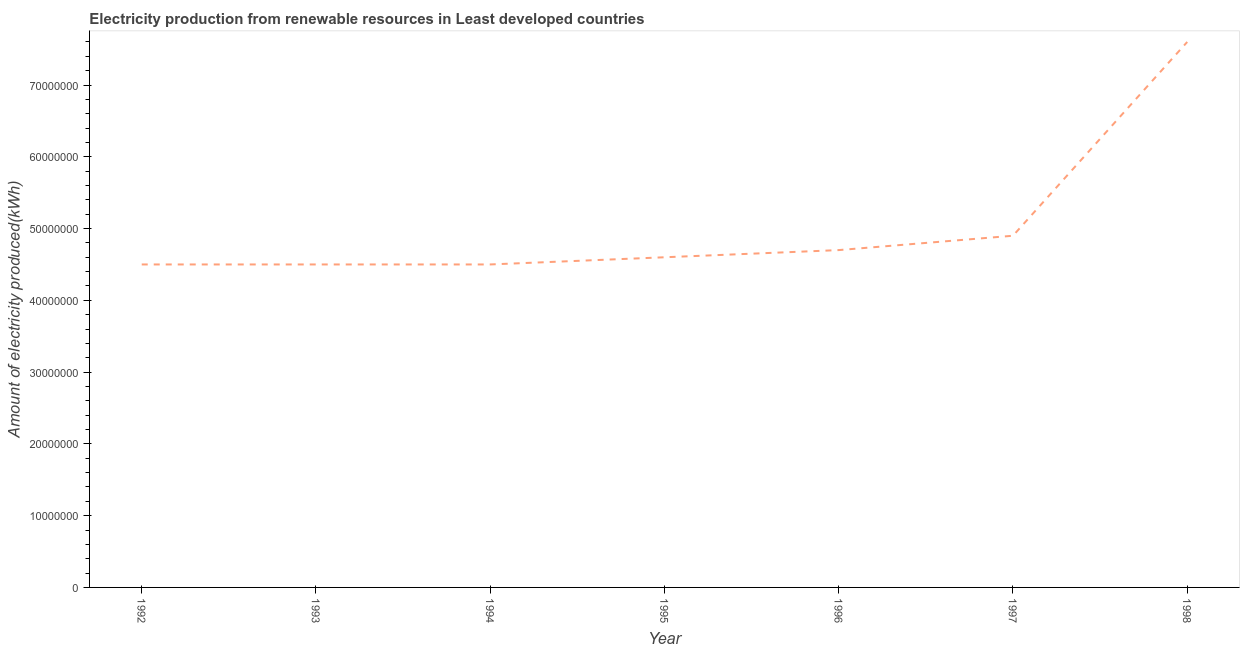What is the amount of electricity produced in 1998?
Your answer should be very brief. 7.60e+07. Across all years, what is the maximum amount of electricity produced?
Your response must be concise. 7.60e+07. Across all years, what is the minimum amount of electricity produced?
Offer a very short reply. 4.50e+07. In which year was the amount of electricity produced minimum?
Provide a short and direct response. 1992. What is the sum of the amount of electricity produced?
Offer a very short reply. 3.53e+08. What is the difference between the amount of electricity produced in 1995 and 1997?
Provide a succinct answer. -3.00e+06. What is the average amount of electricity produced per year?
Your answer should be very brief. 5.04e+07. What is the median amount of electricity produced?
Your answer should be very brief. 4.60e+07. What is the ratio of the amount of electricity produced in 1992 to that in 1996?
Keep it short and to the point. 0.96. Is the amount of electricity produced in 1993 less than that in 1996?
Keep it short and to the point. Yes. Is the difference between the amount of electricity produced in 1996 and 1997 greater than the difference between any two years?
Keep it short and to the point. No. What is the difference between the highest and the second highest amount of electricity produced?
Keep it short and to the point. 2.70e+07. Is the sum of the amount of electricity produced in 1996 and 1998 greater than the maximum amount of electricity produced across all years?
Ensure brevity in your answer.  Yes. What is the difference between the highest and the lowest amount of electricity produced?
Your answer should be compact. 3.10e+07. In how many years, is the amount of electricity produced greater than the average amount of electricity produced taken over all years?
Provide a short and direct response. 1. How many lines are there?
Your answer should be very brief. 1. Does the graph contain any zero values?
Your answer should be compact. No. Does the graph contain grids?
Give a very brief answer. No. What is the title of the graph?
Ensure brevity in your answer.  Electricity production from renewable resources in Least developed countries. What is the label or title of the X-axis?
Your answer should be compact. Year. What is the label or title of the Y-axis?
Keep it short and to the point. Amount of electricity produced(kWh). What is the Amount of electricity produced(kWh) of 1992?
Your answer should be compact. 4.50e+07. What is the Amount of electricity produced(kWh) of 1993?
Your answer should be very brief. 4.50e+07. What is the Amount of electricity produced(kWh) in 1994?
Give a very brief answer. 4.50e+07. What is the Amount of electricity produced(kWh) in 1995?
Your answer should be very brief. 4.60e+07. What is the Amount of electricity produced(kWh) in 1996?
Provide a short and direct response. 4.70e+07. What is the Amount of electricity produced(kWh) of 1997?
Provide a succinct answer. 4.90e+07. What is the Amount of electricity produced(kWh) in 1998?
Give a very brief answer. 7.60e+07. What is the difference between the Amount of electricity produced(kWh) in 1992 and 1995?
Provide a succinct answer. -1.00e+06. What is the difference between the Amount of electricity produced(kWh) in 1992 and 1997?
Offer a very short reply. -4.00e+06. What is the difference between the Amount of electricity produced(kWh) in 1992 and 1998?
Your response must be concise. -3.10e+07. What is the difference between the Amount of electricity produced(kWh) in 1993 and 1994?
Offer a terse response. 0. What is the difference between the Amount of electricity produced(kWh) in 1993 and 1995?
Give a very brief answer. -1.00e+06. What is the difference between the Amount of electricity produced(kWh) in 1993 and 1998?
Make the answer very short. -3.10e+07. What is the difference between the Amount of electricity produced(kWh) in 1994 and 1997?
Your answer should be very brief. -4.00e+06. What is the difference between the Amount of electricity produced(kWh) in 1994 and 1998?
Provide a short and direct response. -3.10e+07. What is the difference between the Amount of electricity produced(kWh) in 1995 and 1997?
Give a very brief answer. -3.00e+06. What is the difference between the Amount of electricity produced(kWh) in 1995 and 1998?
Give a very brief answer. -3.00e+07. What is the difference between the Amount of electricity produced(kWh) in 1996 and 1998?
Keep it short and to the point. -2.90e+07. What is the difference between the Amount of electricity produced(kWh) in 1997 and 1998?
Keep it short and to the point. -2.70e+07. What is the ratio of the Amount of electricity produced(kWh) in 1992 to that in 1993?
Make the answer very short. 1. What is the ratio of the Amount of electricity produced(kWh) in 1992 to that in 1994?
Your response must be concise. 1. What is the ratio of the Amount of electricity produced(kWh) in 1992 to that in 1995?
Ensure brevity in your answer.  0.98. What is the ratio of the Amount of electricity produced(kWh) in 1992 to that in 1996?
Give a very brief answer. 0.96. What is the ratio of the Amount of electricity produced(kWh) in 1992 to that in 1997?
Your response must be concise. 0.92. What is the ratio of the Amount of electricity produced(kWh) in 1992 to that in 1998?
Give a very brief answer. 0.59. What is the ratio of the Amount of electricity produced(kWh) in 1993 to that in 1997?
Give a very brief answer. 0.92. What is the ratio of the Amount of electricity produced(kWh) in 1993 to that in 1998?
Your response must be concise. 0.59. What is the ratio of the Amount of electricity produced(kWh) in 1994 to that in 1995?
Give a very brief answer. 0.98. What is the ratio of the Amount of electricity produced(kWh) in 1994 to that in 1997?
Offer a very short reply. 0.92. What is the ratio of the Amount of electricity produced(kWh) in 1994 to that in 1998?
Your answer should be compact. 0.59. What is the ratio of the Amount of electricity produced(kWh) in 1995 to that in 1997?
Offer a terse response. 0.94. What is the ratio of the Amount of electricity produced(kWh) in 1995 to that in 1998?
Give a very brief answer. 0.6. What is the ratio of the Amount of electricity produced(kWh) in 1996 to that in 1998?
Your response must be concise. 0.62. What is the ratio of the Amount of electricity produced(kWh) in 1997 to that in 1998?
Provide a short and direct response. 0.65. 